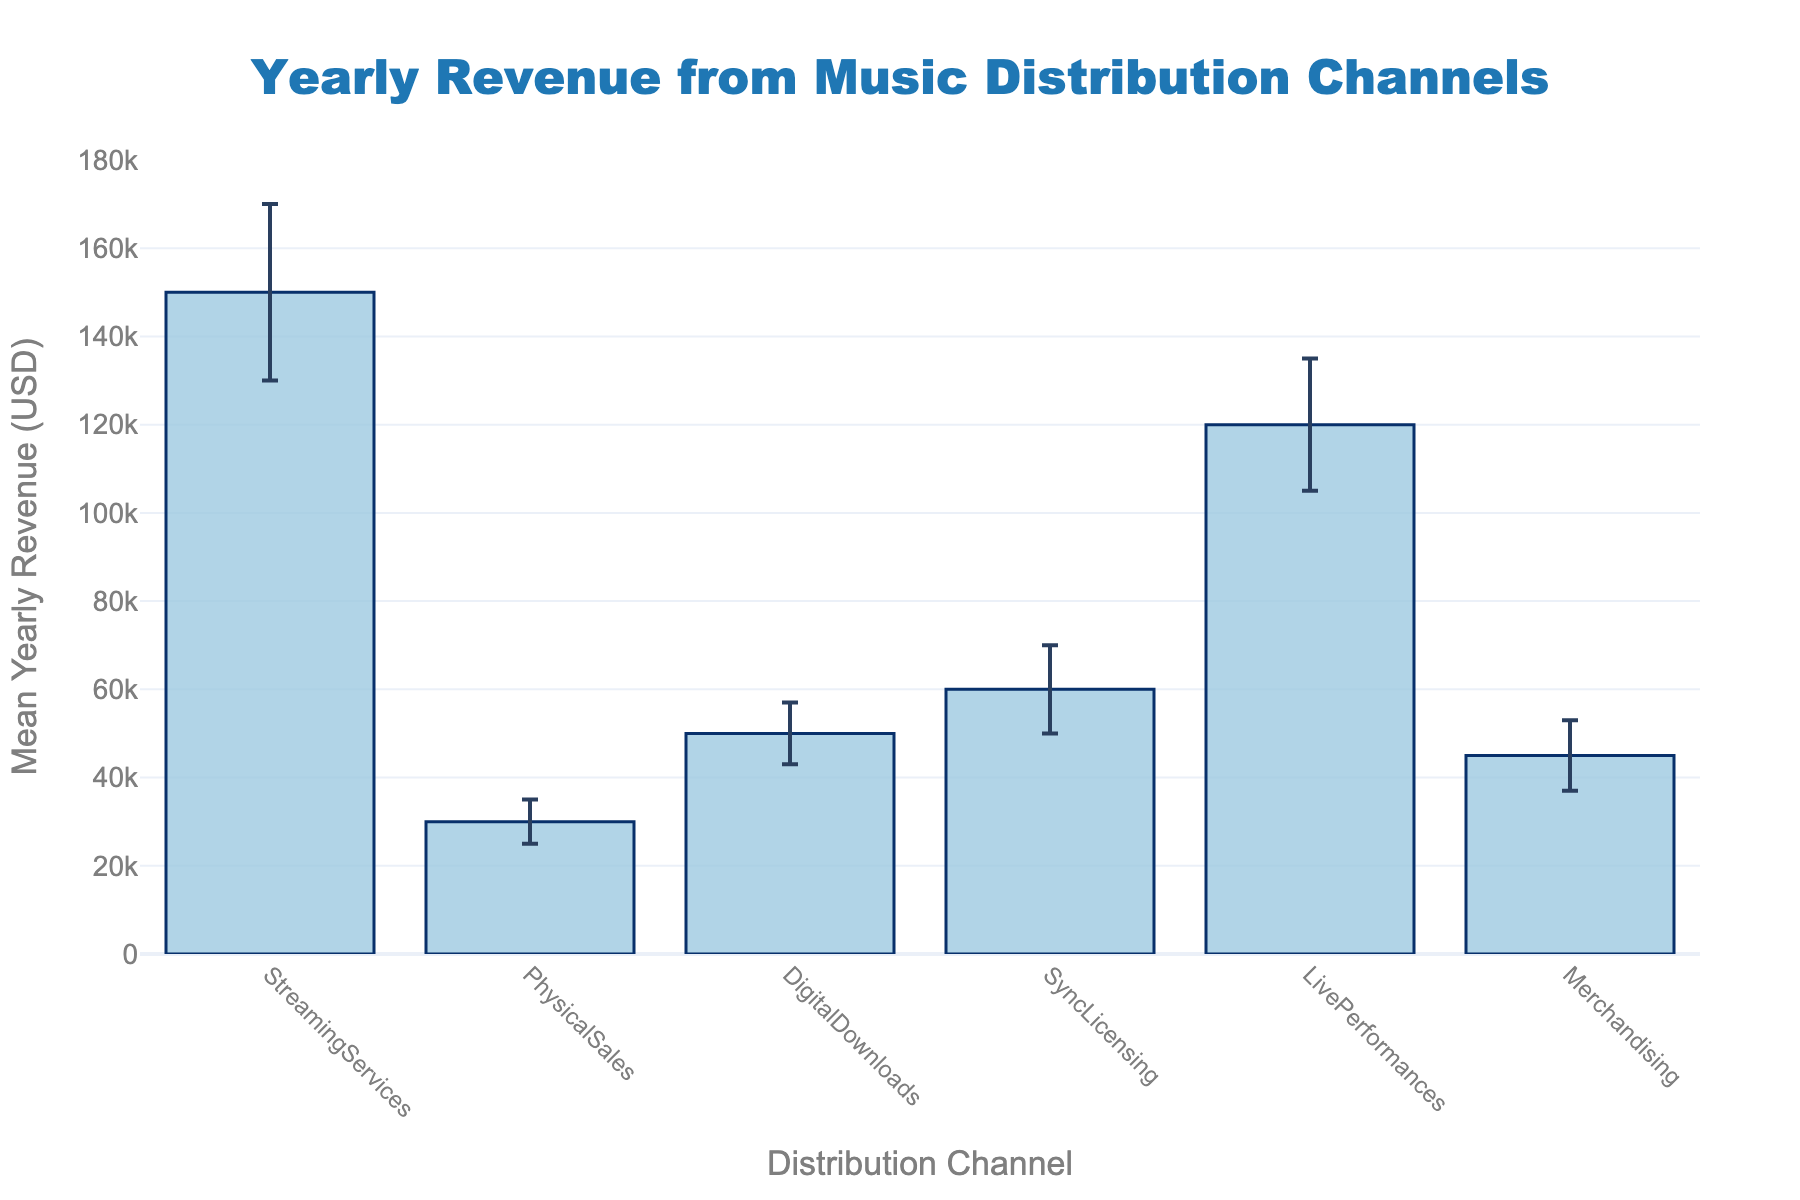What is the title of the figure? The title of the figure is typically displayed at the top and often with larger font size and bold styling. Here, the title is placed in the middle, just above the plot area.
Answer: Yearly Revenue from Music Distribution Channels What is the mean yearly revenue for Live Performances? Locate the bar representing Live Performances on the x-axis and read off the corresponding value on the y-axis. The label indicates Live Performances at around $120,000.
Answer: $120,000 Which channel has the lowest mean yearly revenue? Identify the shortest bar in the chart and read the label corresponding to this bar on the x-axis. This will be the channel with the lowest revenue. The shortest bar corresponds to Physical Sales.
Answer: Physical Sales How much higher is the revenue from Streaming Services compared to Physical Sales? First, find the mean yearly revenues for both Streaming Services and Physical Sales. Subtract the lower value from the higher one (150,000 - 30,000).
Answer: $120,000 What is the range of mean yearly revenues for the given channels? Identify the highest and lowest mean yearly revenue values from the chart: the highest is from Streaming Services ($150,000) and the lowest from Physical Sales ($30,000). Subtract the minimum value from the maximum value to get the range (150,000 - 30,000).
Answer: $120,000 Which channel has the largest error bar? Locate the bars with error bars (vertical lines extending from the top of the bar) in the plot. The error bar with the largest range indicates the greatest standard deviation. Sync Licensing has the largest error bar.
Answer: Sync Licensing What is the total mean yearly revenue from all channels combined? Sum the mean yearly revenues for all channels: 150,000 (Streaming Services) + 30,000 (Physical Sales) + 50,000 (Digital Downloads) + 60,000 (Sync Licensing) + 120,000 (Live Performances) + 45,000 (Merchandising). This results in 455,000.
Answer: $455,000 How does the mean yearly revenue of Digital Downloads compare to Sync Licensing? Check the mean yearly revenues for both Digital Downloads and Sync Licensing. Digital Downloads has $50,000, while Sync Licensing has $60,000. Thus, Sync Licensing has a higher revenue than Digital Downloads.
Answer: Sync Licensing is higher by $10,000 Which channels have a mean yearly revenue greater than $50,000? Identify the bars in the graph that reach above the $50,000 mark on the y-axis. These channels are Streaming Services ($150,000), Sync Licensing ($60,000), Live Performances ($120,000), and Merchandising ($45,000) surpasses by a small margin when considering error.
Answer: Streaming Services, Sync Licensing, Live Performances What is the standard deviation of revenue for Merchandising? Locate the bar representing Merchandising and look at the error bar range. The height of this error bar corresponds to the standard deviation given in the data, which is $8,000.
Answer: $8,000 